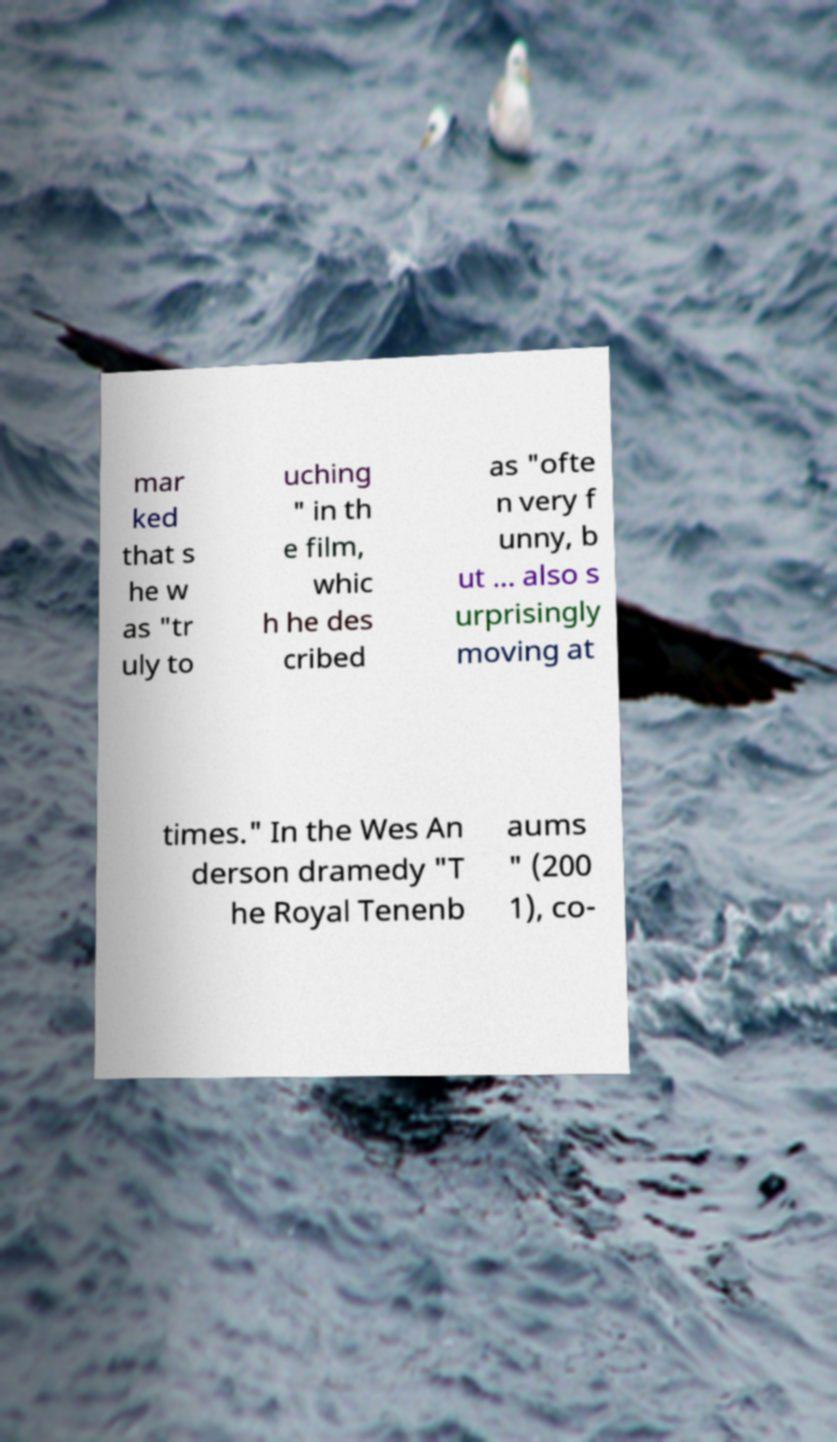I need the written content from this picture converted into text. Can you do that? mar ked that s he w as "tr uly to uching " in th e film, whic h he des cribed as "ofte n very f unny, b ut ... also s urprisingly moving at times." In the Wes An derson dramedy "T he Royal Tenenb aums " (200 1), co- 